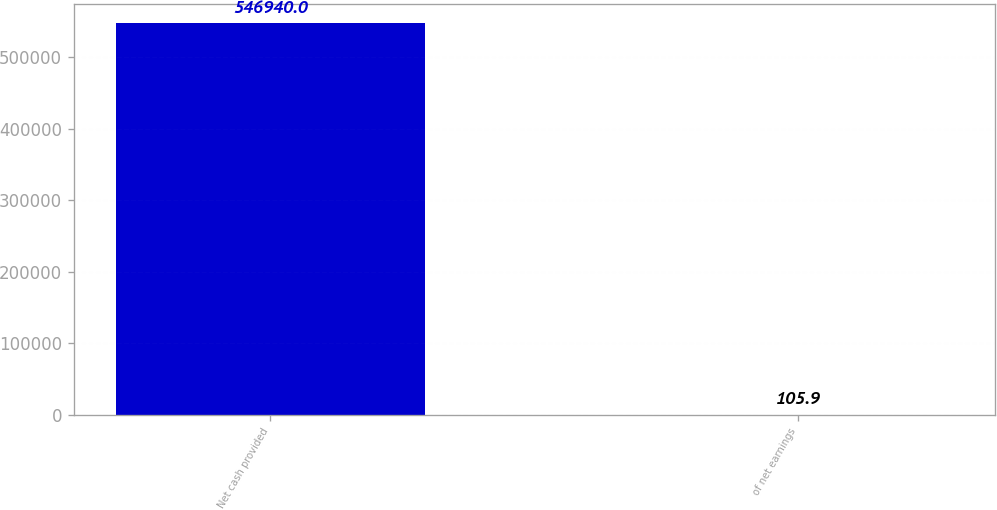Convert chart. <chart><loc_0><loc_0><loc_500><loc_500><bar_chart><fcel>Net cash provided<fcel>of net earnings<nl><fcel>546940<fcel>105.9<nl></chart> 